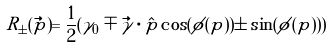<formula> <loc_0><loc_0><loc_500><loc_500>R _ { \pm } ( \vec { p } ) = \frac { 1 } { 2 } ( \gamma _ { 0 } \mp \vec { \gamma } \cdot \hat { p } \cos ( \phi ( p ) ) \pm \sin ( \phi ( p ) ) )</formula> 